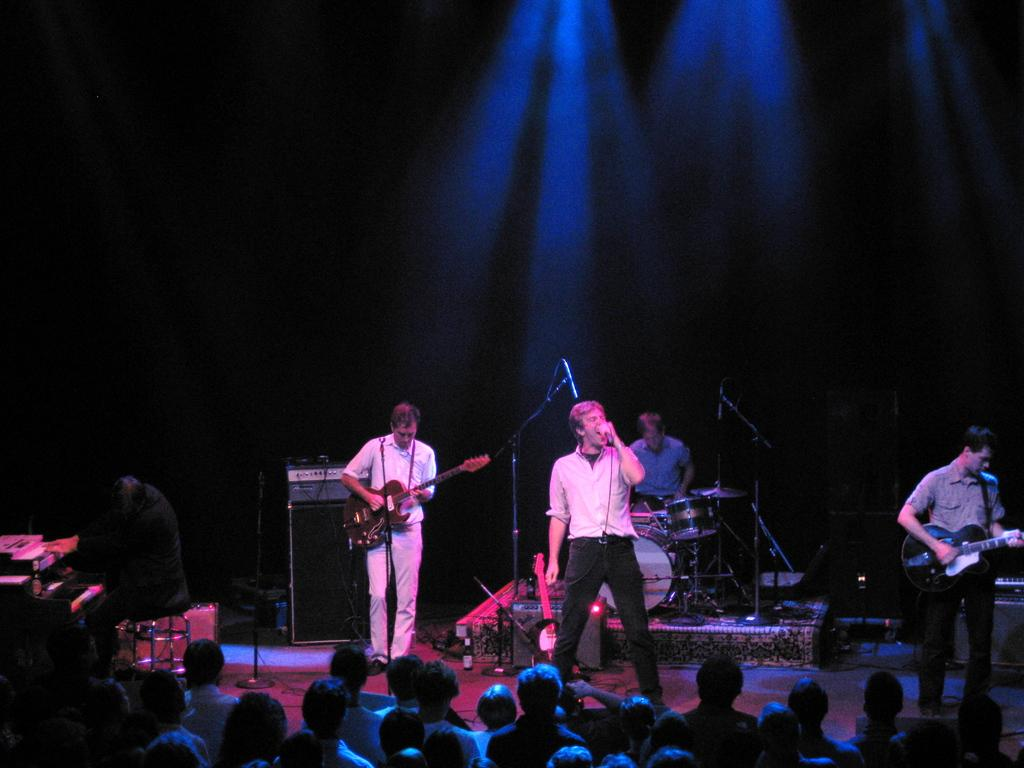What are the people in the image doing? The people in the image are playing musical instruments. Can you describe the scene in the image? There is a group of people in front of the musicians. What type of flight can be seen in the image? There is no flight present in the image; it features people playing musical instruments and a group of people in front of them. What kind of waste is visible in the image? There is no waste visible in the image. 